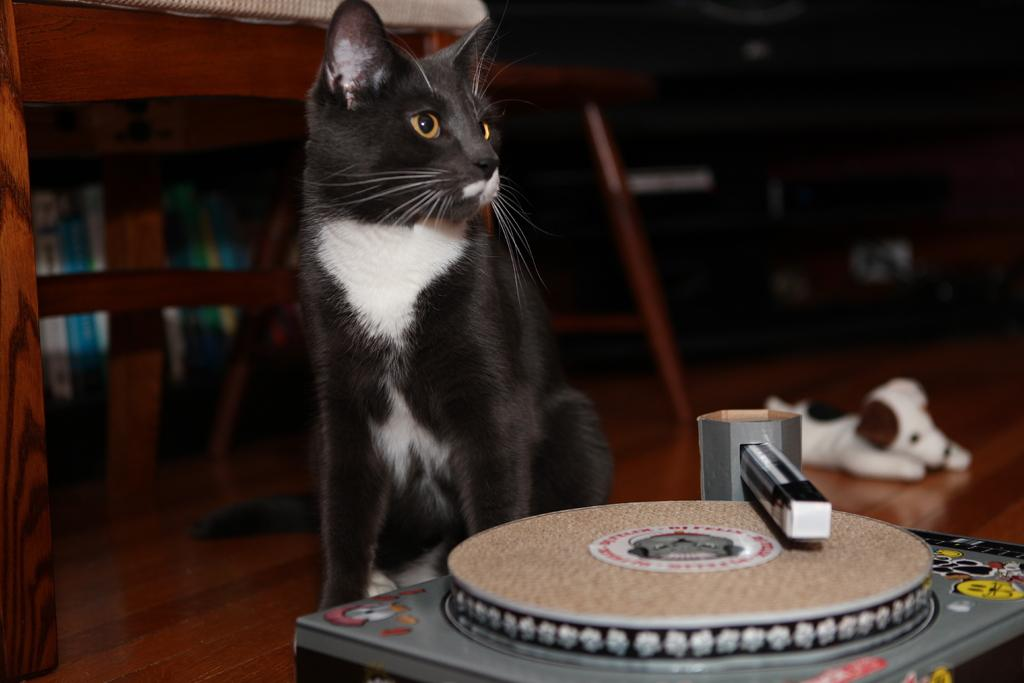What is on the floor in the image? There is a toy on the floor in the image. What type of animal is present in the image? There is a cat in the image. What piece of furniture can be seen in the image? There is a table in the image. What else can be seen in the image besides the toy, cat, and table? There are some objects in the image. How would you describe the lighting in the image? The background of the image is dark. How does the cat participate in the trade depicted in the image? There is no trade depicted in the image, and the cat is not shown participating in any activity related to trade. 